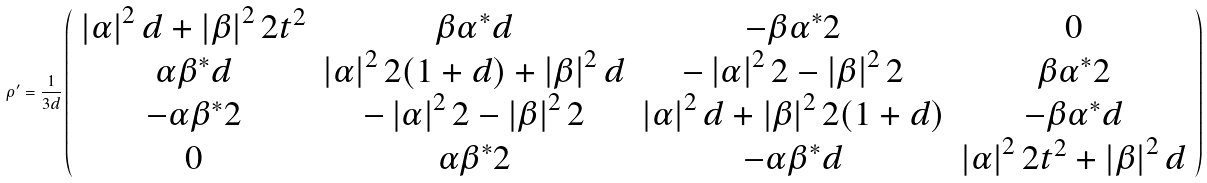Convert formula to latex. <formula><loc_0><loc_0><loc_500><loc_500>\rho ^ { \prime } = \frac { 1 } { 3 d } \left ( \begin{array} { c c c c } \left | \alpha \right | ^ { 2 } d + \left | \beta \right | ^ { 2 } 2 t ^ { 2 } & \beta \alpha ^ { \ast } d & - \beta \alpha ^ { \ast } 2 & 0 \\ \alpha \beta ^ { \ast } d & \left | \alpha \right | ^ { 2 } 2 ( 1 + d ) + \left | \beta \right | ^ { 2 } d & - \left | \alpha \right | ^ { 2 } 2 - \left | \beta \right | ^ { 2 } 2 & \beta \alpha ^ { \ast } 2 \\ - \alpha \beta ^ { \ast } 2 & - \left | \alpha \right | ^ { 2 } 2 - \left | \beta \right | ^ { 2 } 2 & \left | \alpha \right | ^ { 2 } d + \left | \beta \right | ^ { 2 } 2 ( 1 + d ) & - \beta \alpha ^ { \ast } d \\ 0 & \alpha \beta ^ { \ast } 2 & - \alpha \beta ^ { \ast } d & \left | \alpha \right | ^ { 2 } 2 t ^ { 2 } + \left | \beta \right | ^ { 2 } d \end{array} \right )</formula> 